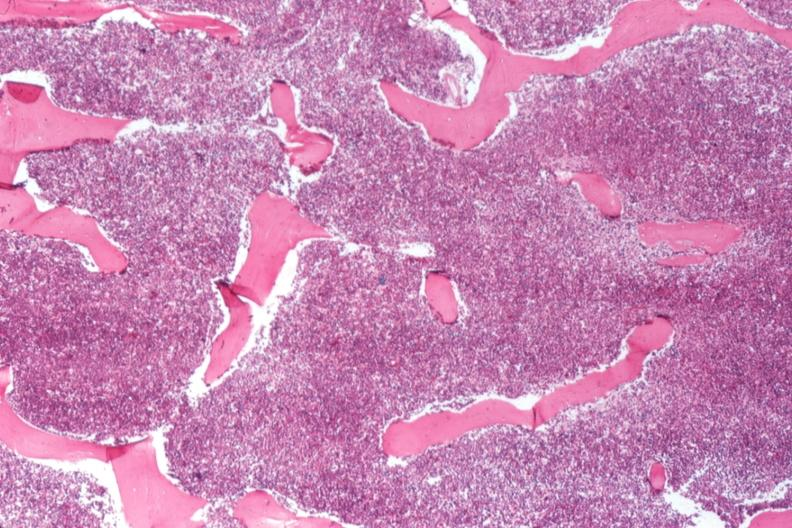s pus in test tube present?
Answer the question using a single word or phrase. No 